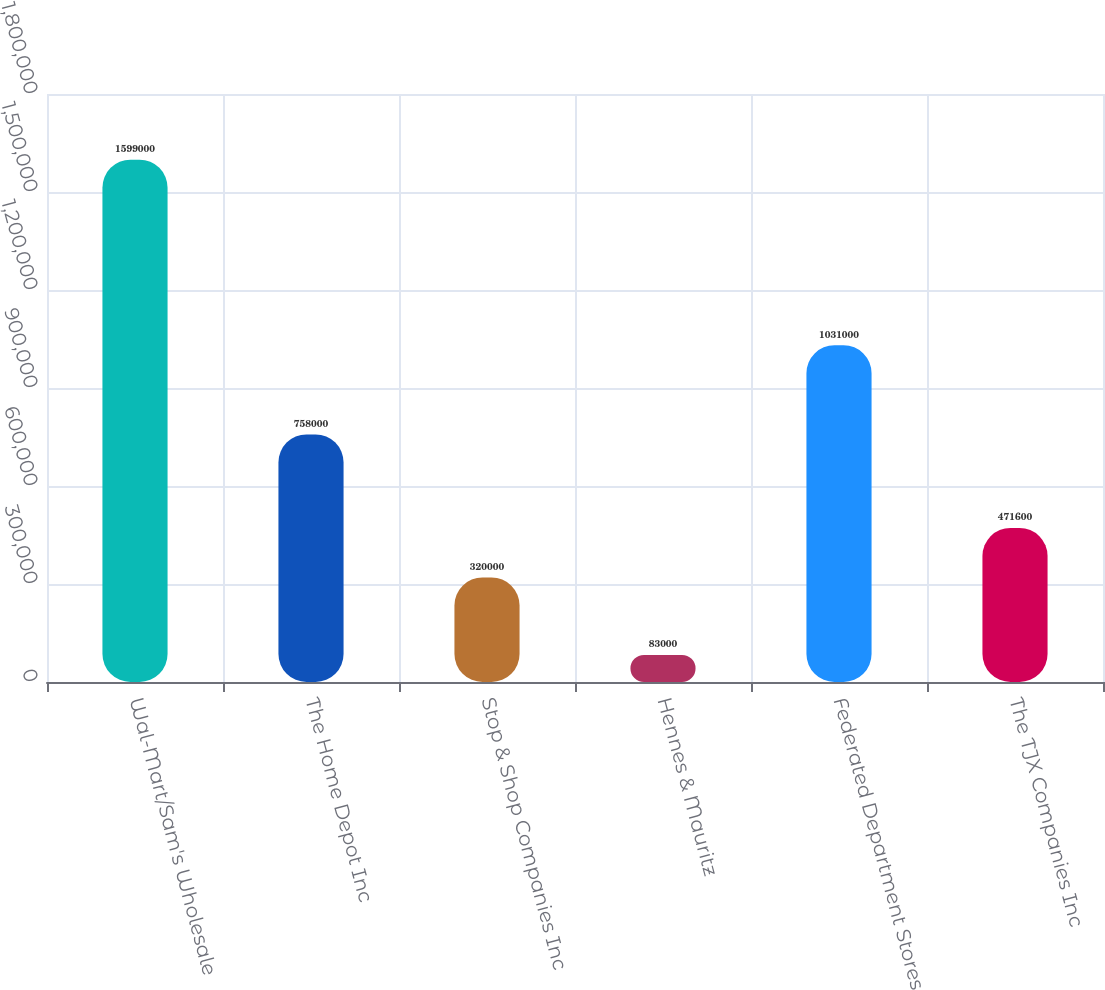Convert chart to OTSL. <chart><loc_0><loc_0><loc_500><loc_500><bar_chart><fcel>Wal-Mart/Sam's Wholesale<fcel>The Home Depot Inc<fcel>Stop & Shop Companies Inc<fcel>Hennes & Mauritz<fcel>Federated Department Stores<fcel>The TJX Companies Inc<nl><fcel>1.599e+06<fcel>758000<fcel>320000<fcel>83000<fcel>1.031e+06<fcel>471600<nl></chart> 